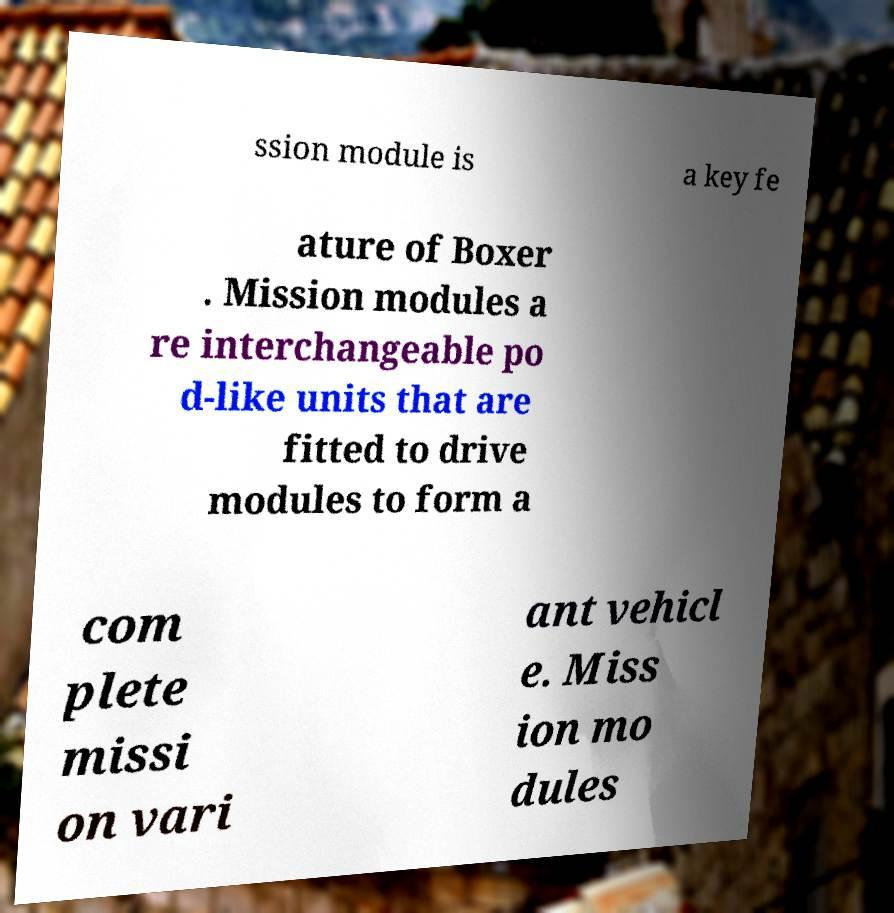There's text embedded in this image that I need extracted. Can you transcribe it verbatim? ssion module is a key fe ature of Boxer . Mission modules a re interchangeable po d-like units that are fitted to drive modules to form a com plete missi on vari ant vehicl e. Miss ion mo dules 